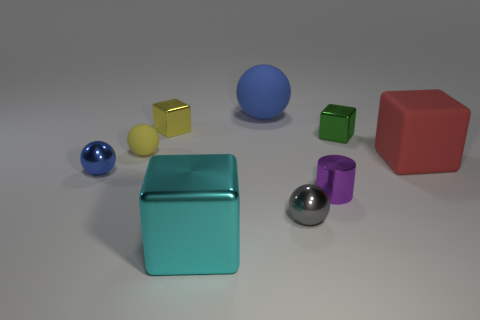Does the tiny yellow ball have the same material as the large cube behind the cyan object?
Offer a very short reply. Yes. There is a cube that is in front of the small green metal object and on the right side of the blue rubber thing; what color is it?
Offer a terse response. Red. How many blocks are either small metal things or yellow metal objects?
Your answer should be compact. 2. Do the large cyan thing and the matte object left of the cyan shiny cube have the same shape?
Provide a succinct answer. No. There is a sphere that is both in front of the red rubber thing and to the left of the cyan shiny block; what is its size?
Offer a very short reply. Small. The small purple metallic thing has what shape?
Offer a very short reply. Cylinder. Is there a big matte sphere that is in front of the yellow thing on the right side of the yellow sphere?
Keep it short and to the point. No. What number of tiny yellow matte balls are left of the small metallic thing that is left of the yellow matte ball?
Provide a succinct answer. 0. There is a green block that is the same size as the purple object; what is its material?
Your answer should be very brief. Metal. There is a blue thing that is to the left of the cyan thing; is its shape the same as the large cyan thing?
Your answer should be very brief. No. 